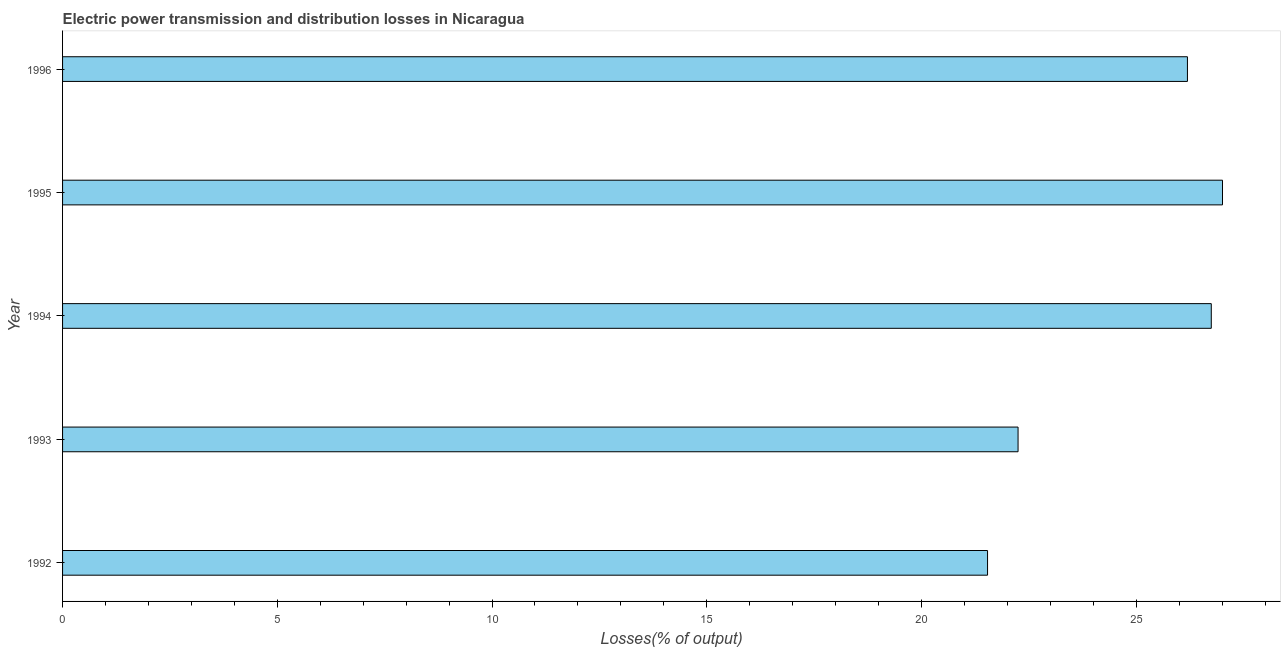What is the title of the graph?
Provide a succinct answer. Electric power transmission and distribution losses in Nicaragua. What is the label or title of the X-axis?
Make the answer very short. Losses(% of output). What is the electric power transmission and distribution losses in 1995?
Ensure brevity in your answer.  27.01. Across all years, what is the maximum electric power transmission and distribution losses?
Give a very brief answer. 27.01. Across all years, what is the minimum electric power transmission and distribution losses?
Offer a very short reply. 21.54. In which year was the electric power transmission and distribution losses maximum?
Keep it short and to the point. 1995. In which year was the electric power transmission and distribution losses minimum?
Give a very brief answer. 1992. What is the sum of the electric power transmission and distribution losses?
Your response must be concise. 123.73. What is the difference between the electric power transmission and distribution losses in 1993 and 1996?
Your response must be concise. -3.94. What is the average electric power transmission and distribution losses per year?
Your answer should be compact. 24.75. What is the median electric power transmission and distribution losses?
Your answer should be very brief. 26.19. In how many years, is the electric power transmission and distribution losses greater than 3 %?
Offer a very short reply. 5. What is the ratio of the electric power transmission and distribution losses in 1992 to that in 1994?
Your answer should be very brief. 0.81. Is the electric power transmission and distribution losses in 1994 less than that in 1995?
Your answer should be compact. Yes. Is the difference between the electric power transmission and distribution losses in 1992 and 1994 greater than the difference between any two years?
Keep it short and to the point. No. What is the difference between the highest and the second highest electric power transmission and distribution losses?
Offer a terse response. 0.26. What is the difference between the highest and the lowest electric power transmission and distribution losses?
Make the answer very short. 5.47. How many bars are there?
Make the answer very short. 5. Are all the bars in the graph horizontal?
Keep it short and to the point. Yes. How many years are there in the graph?
Your response must be concise. 5. What is the difference between two consecutive major ticks on the X-axis?
Your answer should be very brief. 5. Are the values on the major ticks of X-axis written in scientific E-notation?
Provide a succinct answer. No. What is the Losses(% of output) of 1992?
Offer a very short reply. 21.54. What is the Losses(% of output) of 1993?
Your response must be concise. 22.25. What is the Losses(% of output) in 1994?
Your answer should be very brief. 26.75. What is the Losses(% of output) in 1995?
Offer a terse response. 27.01. What is the Losses(% of output) of 1996?
Provide a succinct answer. 26.19. What is the difference between the Losses(% of output) in 1992 and 1993?
Make the answer very short. -0.71. What is the difference between the Losses(% of output) in 1992 and 1994?
Provide a succinct answer. -5.21. What is the difference between the Losses(% of output) in 1992 and 1995?
Your answer should be compact. -5.47. What is the difference between the Losses(% of output) in 1992 and 1996?
Provide a succinct answer. -4.65. What is the difference between the Losses(% of output) in 1993 and 1994?
Provide a short and direct response. -4.5. What is the difference between the Losses(% of output) in 1993 and 1995?
Provide a short and direct response. -4.76. What is the difference between the Losses(% of output) in 1993 and 1996?
Provide a short and direct response. -3.94. What is the difference between the Losses(% of output) in 1994 and 1995?
Make the answer very short. -0.26. What is the difference between the Losses(% of output) in 1994 and 1996?
Provide a short and direct response. 0.56. What is the difference between the Losses(% of output) in 1995 and 1996?
Provide a succinct answer. 0.82. What is the ratio of the Losses(% of output) in 1992 to that in 1993?
Provide a short and direct response. 0.97. What is the ratio of the Losses(% of output) in 1992 to that in 1994?
Keep it short and to the point. 0.81. What is the ratio of the Losses(% of output) in 1992 to that in 1995?
Give a very brief answer. 0.8. What is the ratio of the Losses(% of output) in 1992 to that in 1996?
Provide a short and direct response. 0.82. What is the ratio of the Losses(% of output) in 1993 to that in 1994?
Offer a terse response. 0.83. What is the ratio of the Losses(% of output) in 1993 to that in 1995?
Give a very brief answer. 0.82. What is the ratio of the Losses(% of output) in 1993 to that in 1996?
Ensure brevity in your answer.  0.85. What is the ratio of the Losses(% of output) in 1994 to that in 1995?
Provide a short and direct response. 0.99. What is the ratio of the Losses(% of output) in 1995 to that in 1996?
Provide a short and direct response. 1.03. 